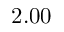<formula> <loc_0><loc_0><loc_500><loc_500>2 . 0 0</formula> 